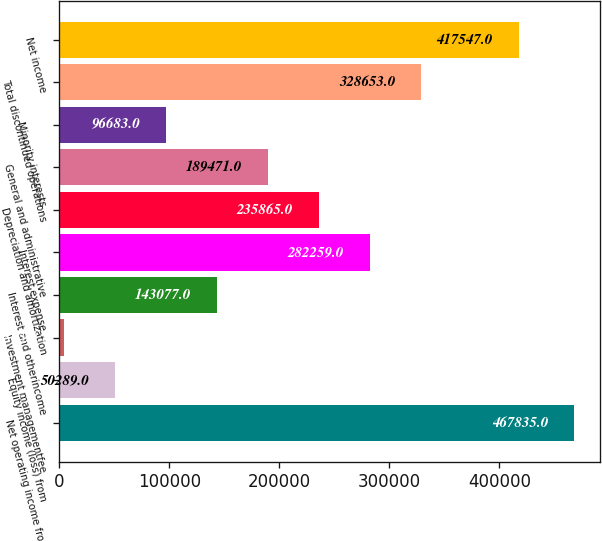<chart> <loc_0><loc_0><loc_500><loc_500><bar_chart><fcel>Net operating income from<fcel>Equity income (loss) from<fcel>Investment managementfee<fcel>Interest and otherincome<fcel>Interest expense<fcel>Depreciation and amortization<fcel>General and administrative<fcel>Minority interests<fcel>Total discontinued operations<fcel>Net income<nl><fcel>467835<fcel>50289<fcel>3895<fcel>143077<fcel>282259<fcel>235865<fcel>189471<fcel>96683<fcel>328653<fcel>417547<nl></chart> 